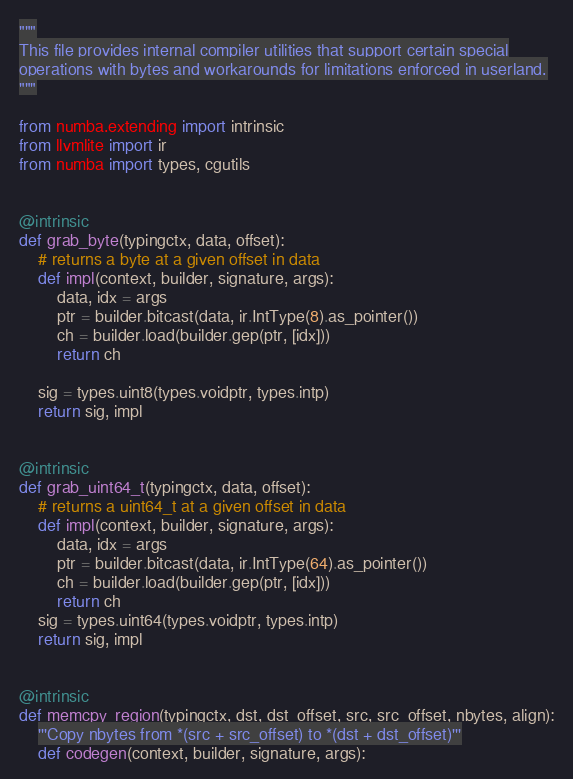<code> <loc_0><loc_0><loc_500><loc_500><_Python_>"""
This file provides internal compiler utilities that support certain special
operations with bytes and workarounds for limitations enforced in userland.
"""

from numba.extending import intrinsic
from llvmlite import ir
from numba import types, cgutils


@intrinsic
def grab_byte(typingctx, data, offset):
    # returns a byte at a given offset in data
    def impl(context, builder, signature, args):
        data, idx = args
        ptr = builder.bitcast(data, ir.IntType(8).as_pointer())
        ch = builder.load(builder.gep(ptr, [idx]))
        return ch

    sig = types.uint8(types.voidptr, types.intp)
    return sig, impl


@intrinsic
def grab_uint64_t(typingctx, data, offset):
    # returns a uint64_t at a given offset in data
    def impl(context, builder, signature, args):
        data, idx = args
        ptr = builder.bitcast(data, ir.IntType(64).as_pointer())
        ch = builder.load(builder.gep(ptr, [idx]))
        return ch
    sig = types.uint64(types.voidptr, types.intp)
    return sig, impl


@intrinsic
def memcpy_region(typingctx, dst, dst_offset, src, src_offset, nbytes, align):
    '''Copy nbytes from *(src + src_offset) to *(dst + dst_offset)'''
    def codegen(context, builder, signature, args):</code> 